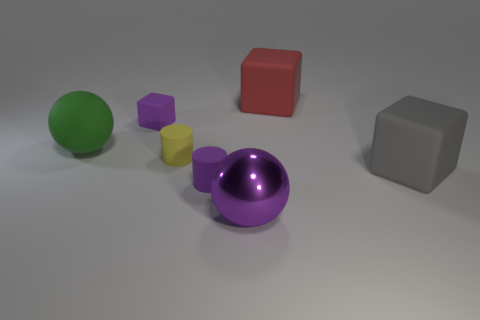Add 2 large gray cubes. How many objects exist? 9 Add 3 big brown shiny things. How many big brown shiny things exist? 3 Subtract all purple spheres. How many spheres are left? 1 Subtract all big rubber blocks. How many blocks are left? 1 Subtract 0 brown balls. How many objects are left? 7 Subtract all balls. How many objects are left? 5 Subtract 1 spheres. How many spheres are left? 1 Subtract all cyan balls. Subtract all gray cylinders. How many balls are left? 2 Subtract all purple balls. How many yellow cylinders are left? 1 Subtract all big green rubber balls. Subtract all big matte things. How many objects are left? 3 